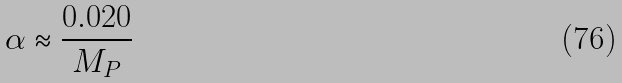<formula> <loc_0><loc_0><loc_500><loc_500>\alpha \approx \frac { 0 . 0 2 0 } { M _ { P } }</formula> 